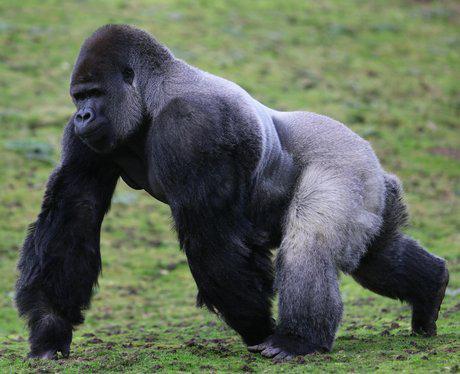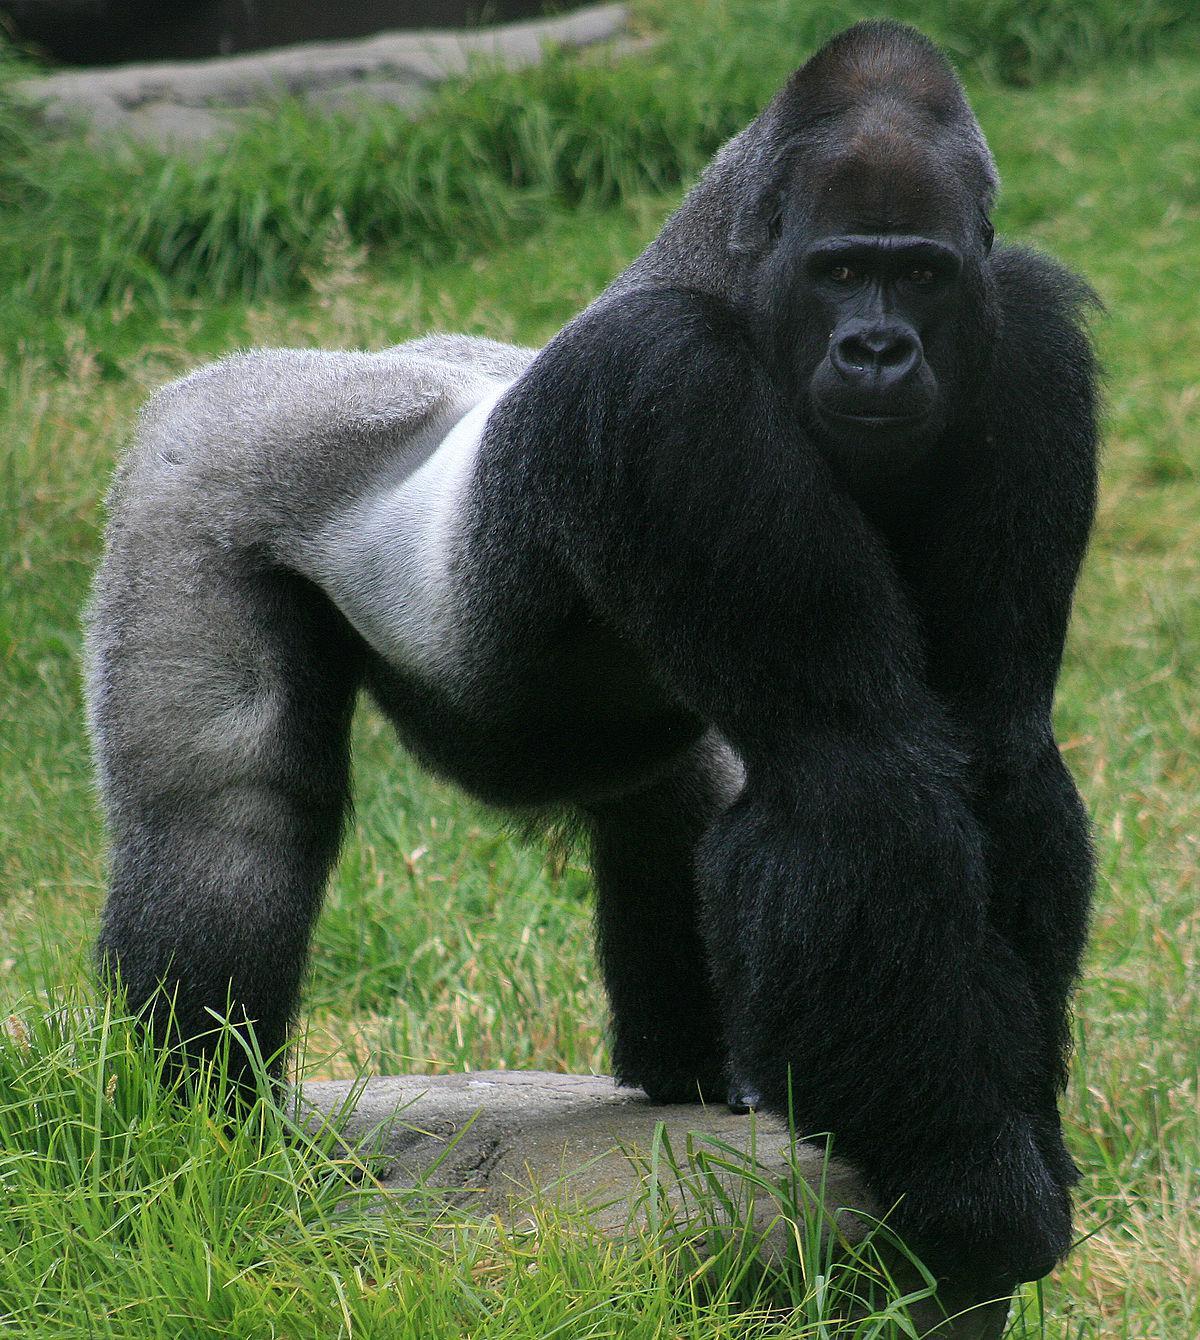The first image is the image on the left, the second image is the image on the right. Examine the images to the left and right. Is the description "there's at least one gorilla sitting" accurate? Answer yes or no. No. 